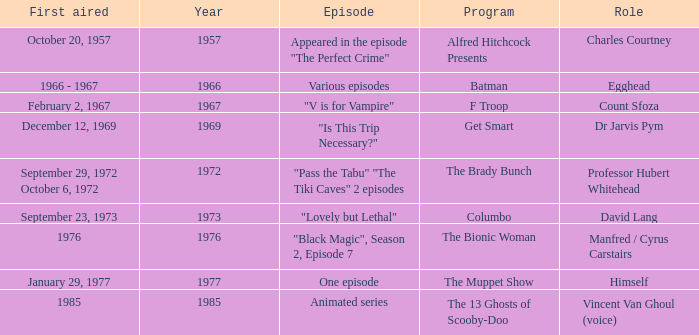What episode was first aired in 1976? "Black Magic", Season 2, Episode 7. 